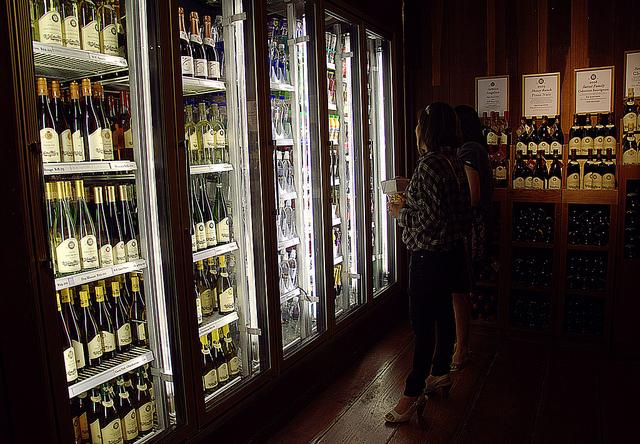Where are these two girls at?

Choices:
A) restaurant
B) liquor store
C) convenience store
D) supermarket liquor store 